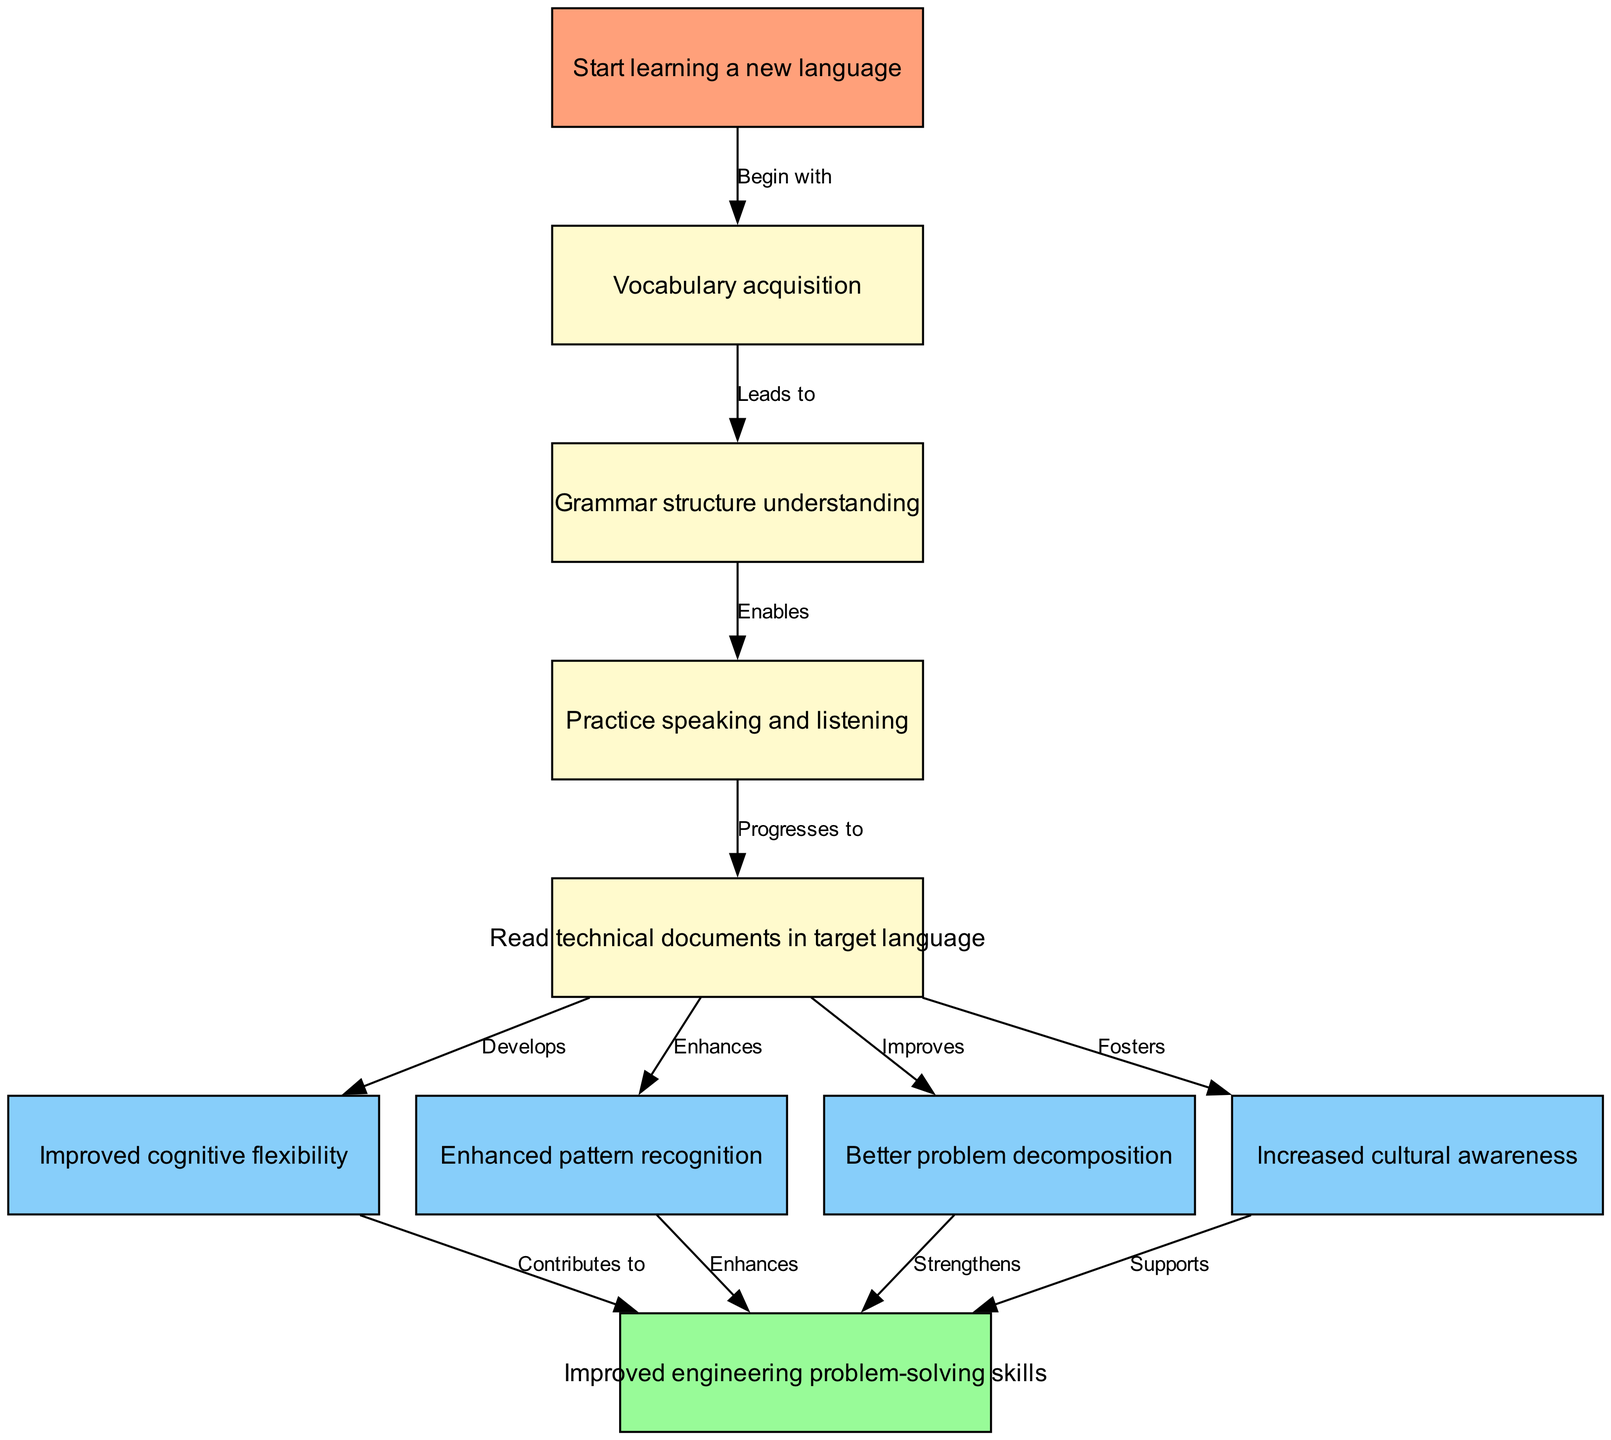What is the first step in the language acquisition process? The diagram indicates that the process starts with "Start learning a new language", which is clearly marked as node 1.
Answer: Start learning a new language How many nodes are present in the diagram? By counting the entries listed in the nodes section of the diagram, we find there are 10 nodes in total.
Answer: 10 What does "Improves" connect to? In the diagram, the edge labeled "Improves" connects the node "Read technical documents in target language" to "Better problem decomposition".
Answer: Better problem decomposition Which node contributes to "Improved engineering problem-solving skills"? The diagram shows that the nodes "Improved cognitive flexibility", "Enhanced pattern recognition", "Better problem decomposition", and "Increased cultural awareness" all contribute to "Improved engineering problem-solving skills".
Answer: Improved cognitive flexibility, Enhanced pattern recognition, Better problem decomposition, Increased cultural awareness What is the role of "Practice speaking and listening" in the language acquisition process? According to the diagram, "Practice speaking and listening" leads to the next step which is "Read technical documents in target language", indicating its enabling role in the process.
Answer: Enables read technical documents in target language Which node supports the improvement of engineering problem-solving skills? The node "Increased cultural awareness" directly supports the improvement of engineering problem-solving skills, as indicated by the diagram's labeled edge.
Answer: Increased cultural awareness How many relationships are shown between nodes in this diagram? By counting all the edges specified in the diagram, it is clear there are 11 relationships connected between the nodes.
Answer: 11 What is the direct effect of "Vocabulary acquisition"? The flow from "Vocabulary acquisition" proceeding to "Grammar structure understanding" shows that the direct effect is leading to that understanding.
Answer: Leads to grammar structure understanding 